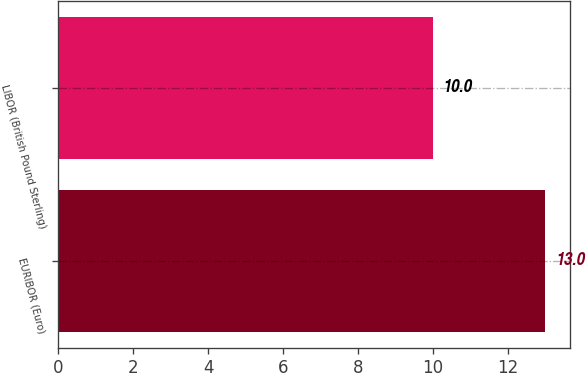Convert chart. <chart><loc_0><loc_0><loc_500><loc_500><bar_chart><fcel>EURIBOR (Euro)<fcel>LIBOR (British Pound Sterling)<nl><fcel>13<fcel>10<nl></chart> 